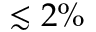Convert formula to latex. <formula><loc_0><loc_0><loc_500><loc_500>\lesssim 2 \%</formula> 